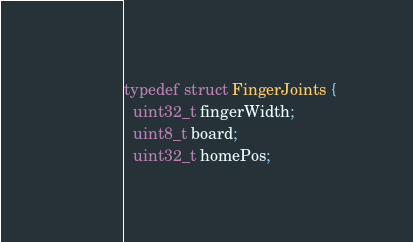<code> <loc_0><loc_0><loc_500><loc_500><_C_>typedef struct FingerJoints {
  uint32_t fingerWidth;
  uint8_t board;
  uint32_t homePos;</code> 